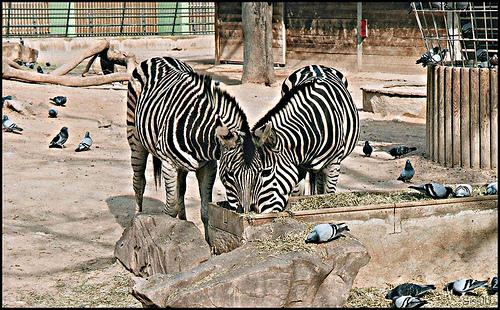Describe any interactions between the different animals within the scene. Two zebras are competing for the same spot at the trough, and pigeons are grazing nearby along with the zebras. Identify any objects that are no longer alive or are in a state of decay within the image. There is a dead, dried-out tree trunk and some fallen tree branches in the image. In simple language, describe the scene involving the zebras. There are two zebras eating in a field, standing near a trough and blending their stripes together. What is the primary activity that the birds are involved in? The birds are grazing on the ground. Analyze the image for any contrasts or repetitions between the various elements present. Some contrasts include the green metal fence against the brown tree trunk and the striped pattern of the zebras' fur. Repetitions can be seen in the stripes of the zebras and the multiple pigeons. Provide a detailed description of the ground in the image. The ground is a mix of clay and dirt with some dessicated grass, rocks, and black shadows. How would you evaluate the overall sentiment or mood of the image? The image has a calm and natural mood, depicting animals interacting peacefully in their environment. Perform a rough count of the number of birds and zebras in the image. There are two zebras and several pigeons in the image. Mention two different types of barriers or fences depicted in the image and describe their colors. There is a green metal fence and a short wooden fence. What season is implied in the image? Probably not late winter. Do you see the yellow sunflower surrounded by the dessicated grass near the boulders? It's a lovely bright color amidst the dry landscape. The given information doesn't mention any sunflower or any such contrasting color in the dry landscape. This instruction is misleading by introducing a non-existent object (sunflower) and inaccurate information about the colors in the image. Can you spot the red bicycle leaning against the trunk of the growing tree? It suggests human activity in the area. There is no bicycle mentioned in the image information. The introduction of the red bicycle is misleading as it suggests the presence of an object that doesn't exist in the image, and falsely implies human activity within the scene. Describe the scene with the two zebras and their surroundings in a poetic manner. Amidst the parched earth and untamed beauty, two zebras vie for sustenance, their patterns dancing a tapestry of life. Describe the texture and patterns found on the zebra fur. The zebra fur has a striped pattern with alternating black and white bands. Explain the purpose of the metal railing and ledge in the image. To protect and provide a boundary between the area with the zebras and the adjacent building. Do you see the man wearing a safari hat, observing the zebras from a safe distance? It seems like he's a tourist or a guide. There is no mention of any human figure in the image information. Introducing the character of a man wearing a safari hat is misleading, as it adds a nonexistent character to the scene and falsely implies the possibility of human interaction in the image. Identify the event occurring between the two zebras. Two zebras competing for the same trough spot. Create a short story that incorporates the zebras and pigeons in the scene. Once upon a time in a dusty field, two zebras, Stripes and Dazzle, jostled for a place at the trough. Nearby, a parliament of pigeons chattered and picked at the earth, amused by the peaceful rivalry of the equine friends. Their days intertwined, a harmony of nature's wild creatures on the edge of the civilized world. Look at the blue sky with fluffy clouds above the zebras. Can you see how the clouds cast shadows on the ground below? There is no mention of a sky or clouds in the image information. The presence of a blue sky and fluffy clouds is inaccurate and misleading, as it introduces elements that don't exist in the image and also falsely attributes the black shadows on the ground to these clouds. Describe the appearance of the fallen tree branches in the image. The fallen tree branches are brown, dry and scattered on the ground. What is the overall situation occurring between the two zebras and surrounding birds? Two zebras are eating from a trough, while birds are grazing on the ground nearby. Write a description of the image for a children's storybook. In a sun-kissed dirt field, two zebras named Ziggy and Zara munch happily from a trough. Nearby, a friendly group of pigeons pecks at the ground, sharing in the feast. The green metal fence keeps them all safe as they enjoy their day together. Notice the mountain range in the background, beyond the birds on the ground. It adds depth and natural beauty to the scene. There is no mention of a mountain range in the image information. This instruction is misleading by adding elements that do not exist in the image and by using descriptive language (such as "depth" and "natural beauty") that may lead the viewer to imagine the mountain range. Can you spot the sleeping lion under the tree on the right side of the image? Look closely, it's resting in the shade. There is no mention of a lion in the given information, so this instruction is misleading by introducing an object that doesn't exist in the image. What mood do the zebras appear to exhibit based on the image? No mood/neutral or content mood while eating. Identify the two animals competing for the same feeding spot in the image. Two zebras. What activity are the two zebras engaging in? Eating from a trough. What is the color of the metal fence? Green. What are the birds on the ground doing? Grazing. Describe the setting with specific reference to the ground and surrounding features. A dirt field with clay, dried grass near boulders, and scattered pigeons near a metal fence and wooden structure. Explain the relationship between the zebras and their environment. The zebras are wild animals coexisting within a manmade habitat, enclosed by a green metal fence, and sharing the environment with birds and other wildlife. What is written on the sign near the zebras in the image? There is no text to read on any signs. Is there any text present on the fence or nearby structures? No. Write a haiku about the two zebras and their environment. Zebras graze and strive, 